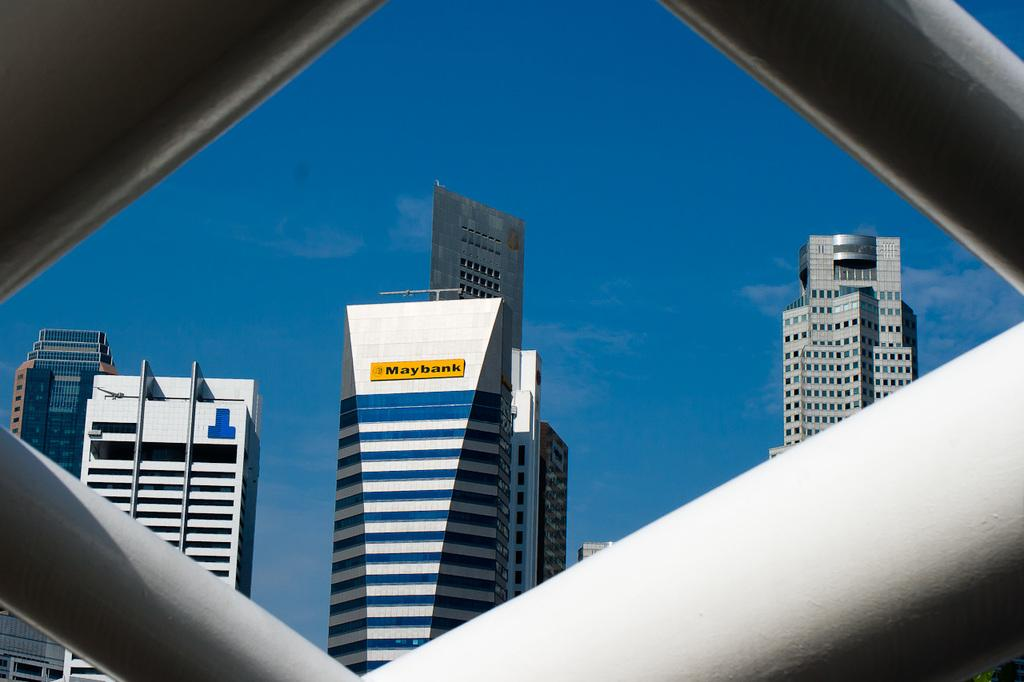What objects can be seen in the foreground of the image? There are iron rods in the image. What structures are visible in the background of the image? There are buildings visible behind the iron rods. What is the condition of the sky in the image? The sky is clear in the image. How many ducks are swimming in the water near the iron rods? There are no ducks or water present in the image; it features iron rods and buildings in the background. 